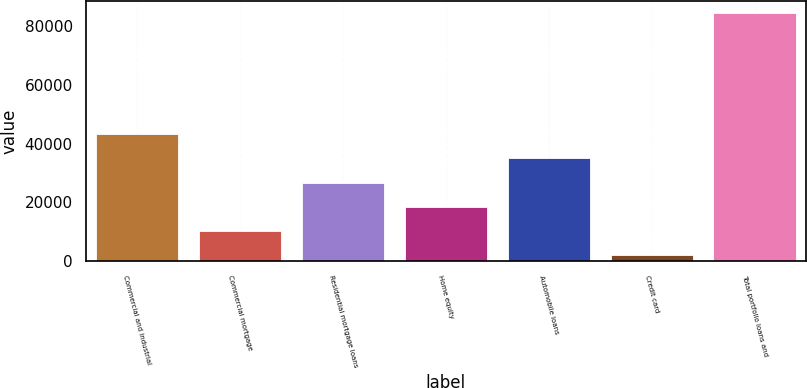<chart> <loc_0><loc_0><loc_500><loc_500><bar_chart><fcel>Commercial and industrial<fcel>Commercial mortgage<fcel>Residential mortgage loans<fcel>Home equity<fcel>Automobile loans<fcel>Credit card<fcel>Total portfolio loans and<nl><fcel>43203<fcel>10260.6<fcel>26731.8<fcel>18496.2<fcel>34967.4<fcel>2025<fcel>84381<nl></chart> 